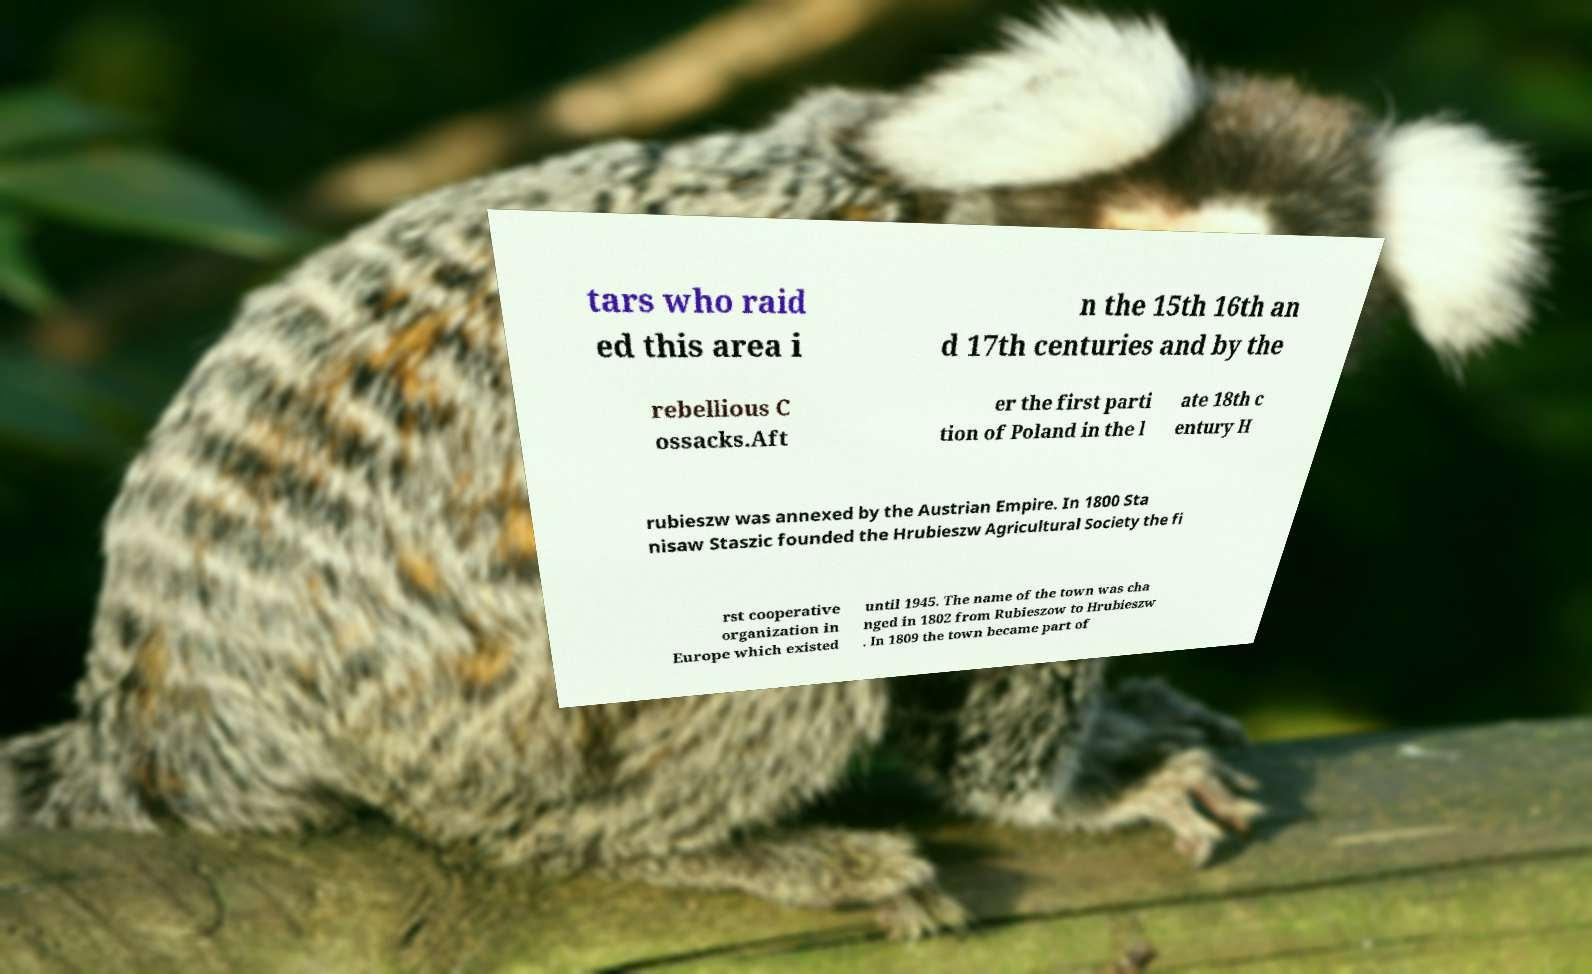Please read and relay the text visible in this image. What does it say? tars who raid ed this area i n the 15th 16th an d 17th centuries and by the rebellious C ossacks.Aft er the first parti tion of Poland in the l ate 18th c entury H rubieszw was annexed by the Austrian Empire. In 1800 Sta nisaw Staszic founded the Hrubieszw Agricultural Society the fi rst cooperative organization in Europe which existed until 1945. The name of the town was cha nged in 1802 from Rubieszow to Hrubieszw . In 1809 the town became part of 